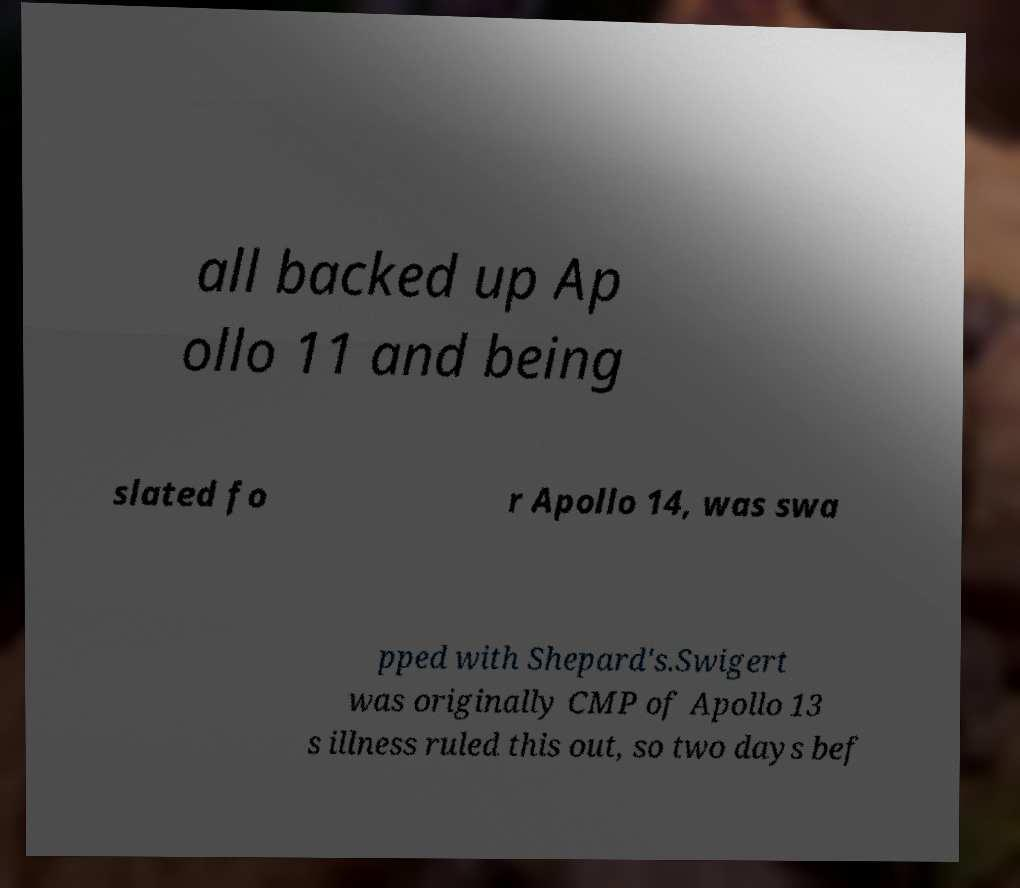Please read and relay the text visible in this image. What does it say? all backed up Ap ollo 11 and being slated fo r Apollo 14, was swa pped with Shepard's.Swigert was originally CMP of Apollo 13 s illness ruled this out, so two days bef 